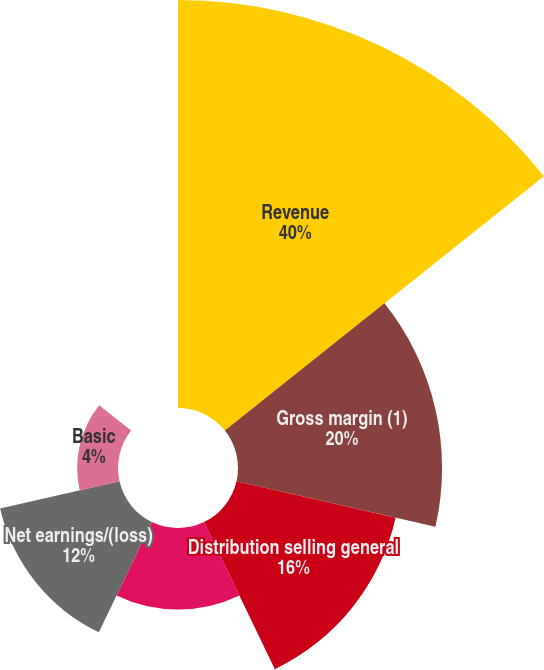Convert chart to OTSL. <chart><loc_0><loc_0><loc_500><loc_500><pie_chart><fcel>Revenue<fcel>Gross margin (1)<fcel>Distribution selling general<fcel>Net earnings/(loss) (2)<fcel>Net earnings/(loss)<fcel>Basic<fcel>Diluted (3)<nl><fcel>39.99%<fcel>20.0%<fcel>16.0%<fcel>8.0%<fcel>12.0%<fcel>4.0%<fcel>0.0%<nl></chart> 